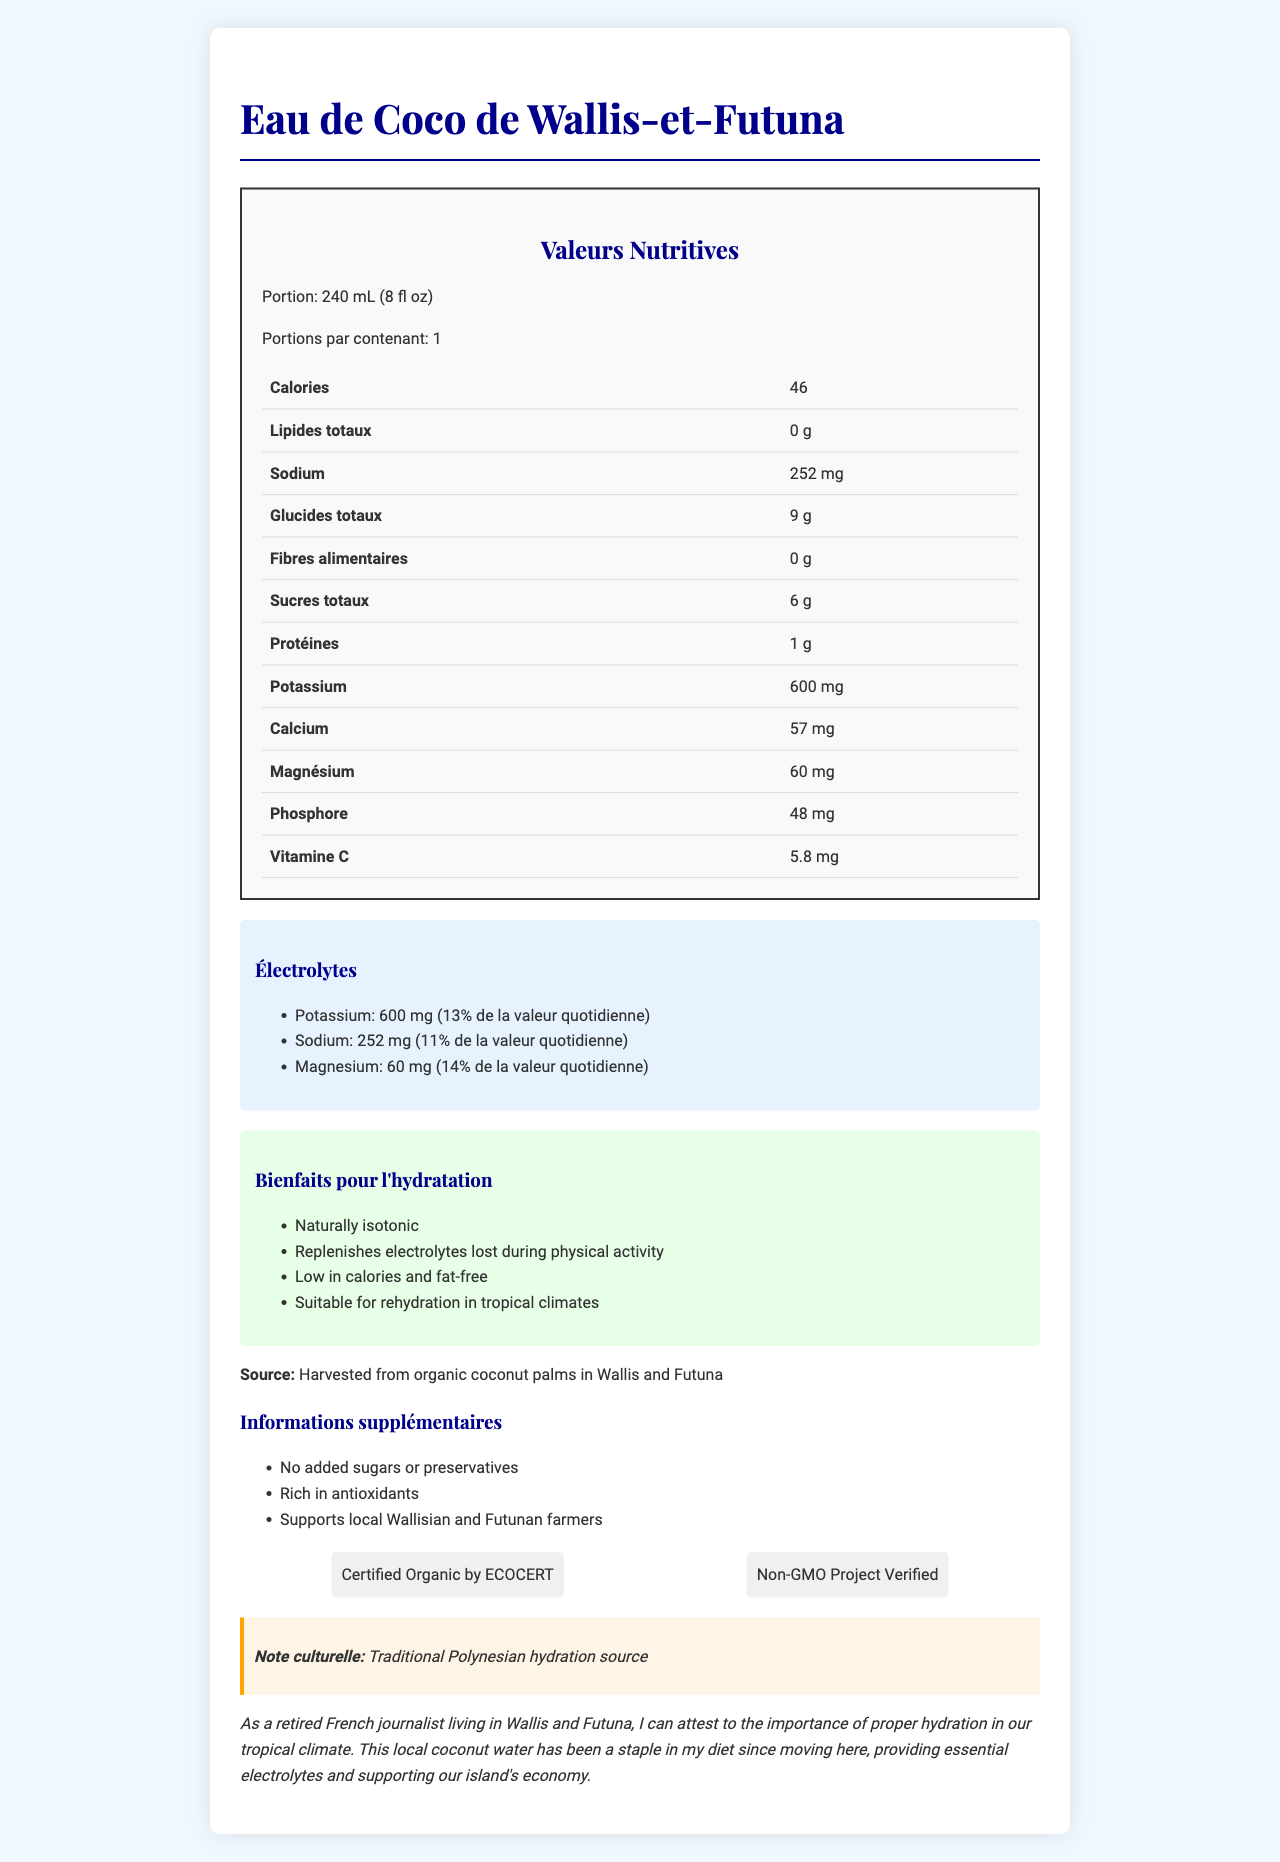What is the serving size for the coconut water? The document states that the serving size is 240 mL, which is equivalent to 8 fluid ounces.
Answer: 240 mL (8 fl oz) How many calories are there per serving? The document clearly indicates that each serving contains 46 calories.
Answer: 46 What is the amount of potassium per serving and its percentage of daily value? The document lists potassium content as 600 mg per serving, which is 13% of the daily value.
Answer: 600 mg, 13% Which electrolyte has the highest daily value percentage? Magnesium is indicated as having 60 mg per serving and represents 14% of the daily value, which is the highest among the listed electrolytes.
Answer: Magnesium, 14% Is there any fat in the coconut water? The document clearly states that the total fat content is 0 g, indicating that it is fat-free.
Answer: No True or False: The coconut water contains added sugars. The additional information section mentions that there are no added sugars or preservatives.
Answer: False Which of the following benefits is not listed under hydration benefits? A) Fat-free B) Replenishes electrolytes C) Aids weight loss D) Low in calories The document lists benefits such as being fat-free, replenishing electrolytes, and being low in calories, but does not mention aiding weight loss.
Answer: C) Aids weight loss The coconut water is organic. Which certification verifies this? A) Non-GMO Project Verified B) Certified Organic by ECOCERT C) Fair Trade Certified D) USDA Organic The document specifically mentions that the product is certified organic by ECOCERT.
Answer: B) Certified Organic by ECOCERT How much sodium does the coconut water contain per serving? The document indicates that the coconut water contains 252 mg of sodium per serving.
Answer: 252 mg Describe the main idea of the document. The document comprehensively presents the nutrient content, hydration benefits, sourcing information, certifications, and the personal experience of a retired French journalist living in Wallis and Futuna, emphasizing the product's natural and organic qualities.
Answer: The main idea of the document is to provide nutritional information about "Eau de Coco de Wallis-et-Futuna" coconut water, highlighting its electrolyte content, hydration benefits, and additional details regarding its natural and organic certifications. What is the source of the coconut water? The document mentions that the coconut water is sourced from organic coconut palms in Wallis and Futuna.
Answer: Harvested from organic coconut palms in Wallis and Futuna Does the coconut water contain any dietary fiber? The document states that the dietary fiber content is 0 g per serving.
Answer: No How many servings are there per container? The document specifies that there is one serving per container.
Answer: 1 What is the calcium content per serving? The document lists the calcium content as 57 mg per serving.
Answer: 57 mg Which of the following is a traditional hydration source mentioned in the cultural note? A) Coconut water B) Herbal tea C) Lemonade D) Sports drinks The document's cultural note states that coconut water is a traditional Polynesian hydration source.
Answer: A) Coconut water What is the farmer's support claim made in the document? The document asserts that the coconut water supports local farmers from Wallis and Futuna.
Answer: Supports local Wallisian and Futunan farmers What is the magnesium content per serving? The document specifies that each serving contains 60 mg of magnesium.
Answer: 60 mg Are there any preservatives added to the coconut water? The additional information section mentions that there are no added preservatives.
Answer: No What is the total carbohydrate content per serving? The document states that there are 9 grams of total carbohydrates per serving.
Answer: 9 g Does the document provide details on the harvesting method for coconut water? The document mentions the source as organic coconut palms but does not describe the specific harvesting method.
Answer: Not enough information 